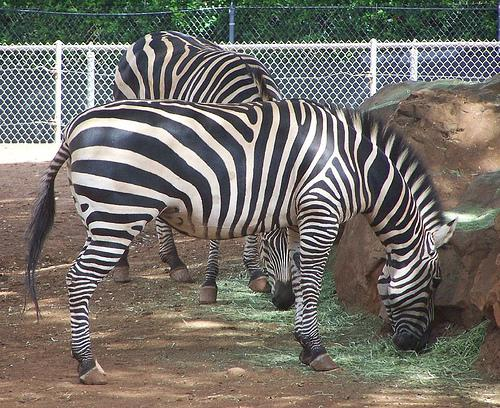Question: who is present?
Choices:
A. Nobody.
B. A man.
C. A woman.
D. A child.
Answer with the letter. Answer: A Question: what are they doing?
Choices:
A. Grazing.
B. Fleeing.
C. Sleeping.
D. Fighting.
Answer with the letter. Answer: A Question: what are they?
Choices:
A. Zebras.
B. Elephants.
C. Lions.
D. Hippos.
Answer with the letter. Answer: A Question: where was this photo taken?
Choices:
A. At the park.
B. At the zoo.
C. At my house.
D. On the couch.
Answer with the letter. Answer: B 